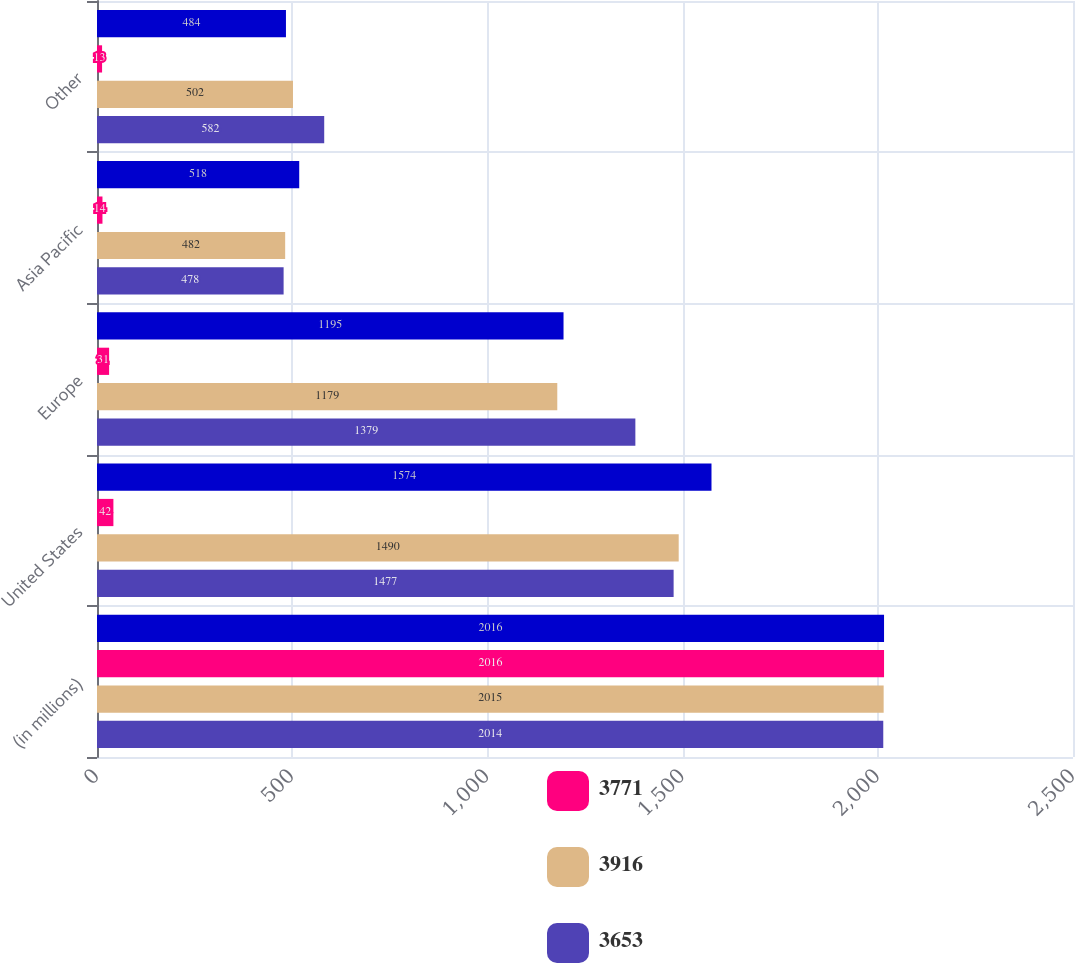<chart> <loc_0><loc_0><loc_500><loc_500><stacked_bar_chart><ecel><fcel>(in millions)<fcel>United States<fcel>Europe<fcel>Asia Pacific<fcel>Other<nl><fcel>nan<fcel>2016<fcel>1574<fcel>1195<fcel>518<fcel>484<nl><fcel>3771<fcel>2016<fcel>42<fcel>31<fcel>14<fcel>13<nl><fcel>3916<fcel>2015<fcel>1490<fcel>1179<fcel>482<fcel>502<nl><fcel>3653<fcel>2014<fcel>1477<fcel>1379<fcel>478<fcel>582<nl></chart> 